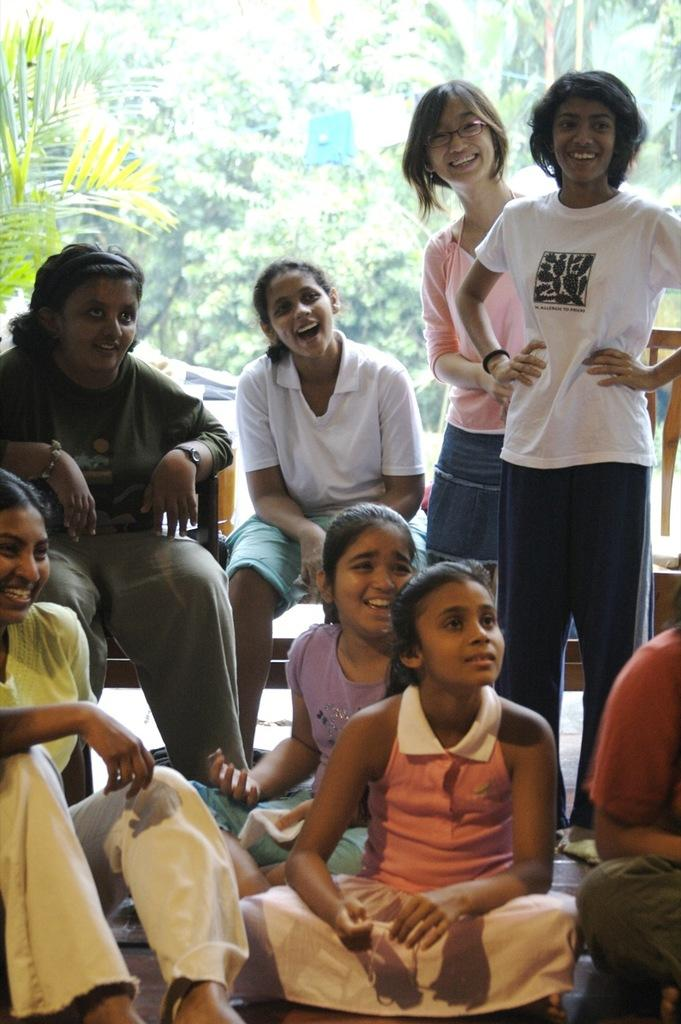Who is present in the image? There are children in the image. What are the children wearing? The children are wearing different color dresses. What is the emotional state of the children? The children are smiling. What positions are the children in? Some of the children are sitting. What can be seen in the background of the image? There are trees in the background of the image. What rule is being enforced by the children in the image? There is no indication of any rule being enforced in the image; the children are simply smiling and wearing different color dresses. 